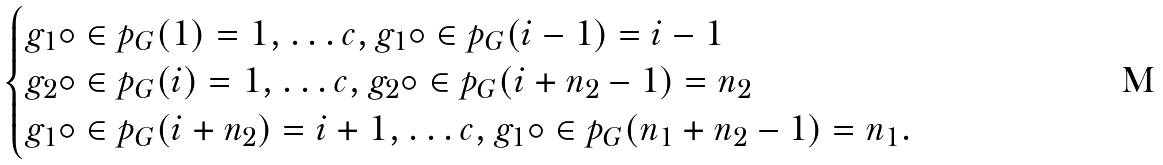Convert formula to latex. <formula><loc_0><loc_0><loc_500><loc_500>\begin{cases} g _ { 1 } \circ \in p _ { G } ( 1 ) = 1 , \dots c , g _ { 1 } \circ \in p _ { G } ( i - 1 ) = i - 1 \\ g _ { 2 } \circ \in p _ { G } ( i ) = 1 , \dots c , g _ { 2 } \circ \in p _ { G } ( i + n _ { 2 } - 1 ) = n _ { 2 } \\ g _ { 1 } \circ \in p _ { G } ( i + n _ { 2 } ) = i + 1 , \dots c , g _ { 1 } \circ \in p _ { G } ( n _ { 1 } + n _ { 2 } - 1 ) = n _ { 1 } . \end{cases}</formula> 